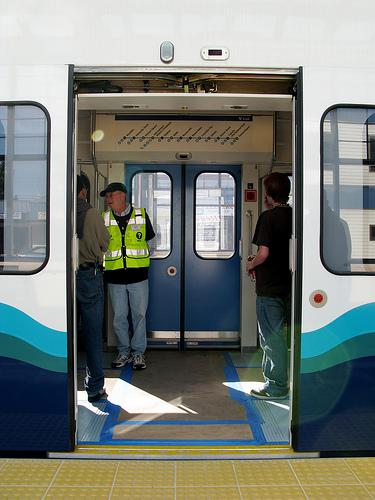Question: what color is the jacket?
Choices:
A. Blue.
B. Red.
C. Neon green.
D. Black.
Answer with the letter. Answer: C Question: who is driving the bus?
Choices:
A. The instuctor.
B. The student driver.
C. The manager.
D. The bus driver.
Answer with the letter. Answer: D 